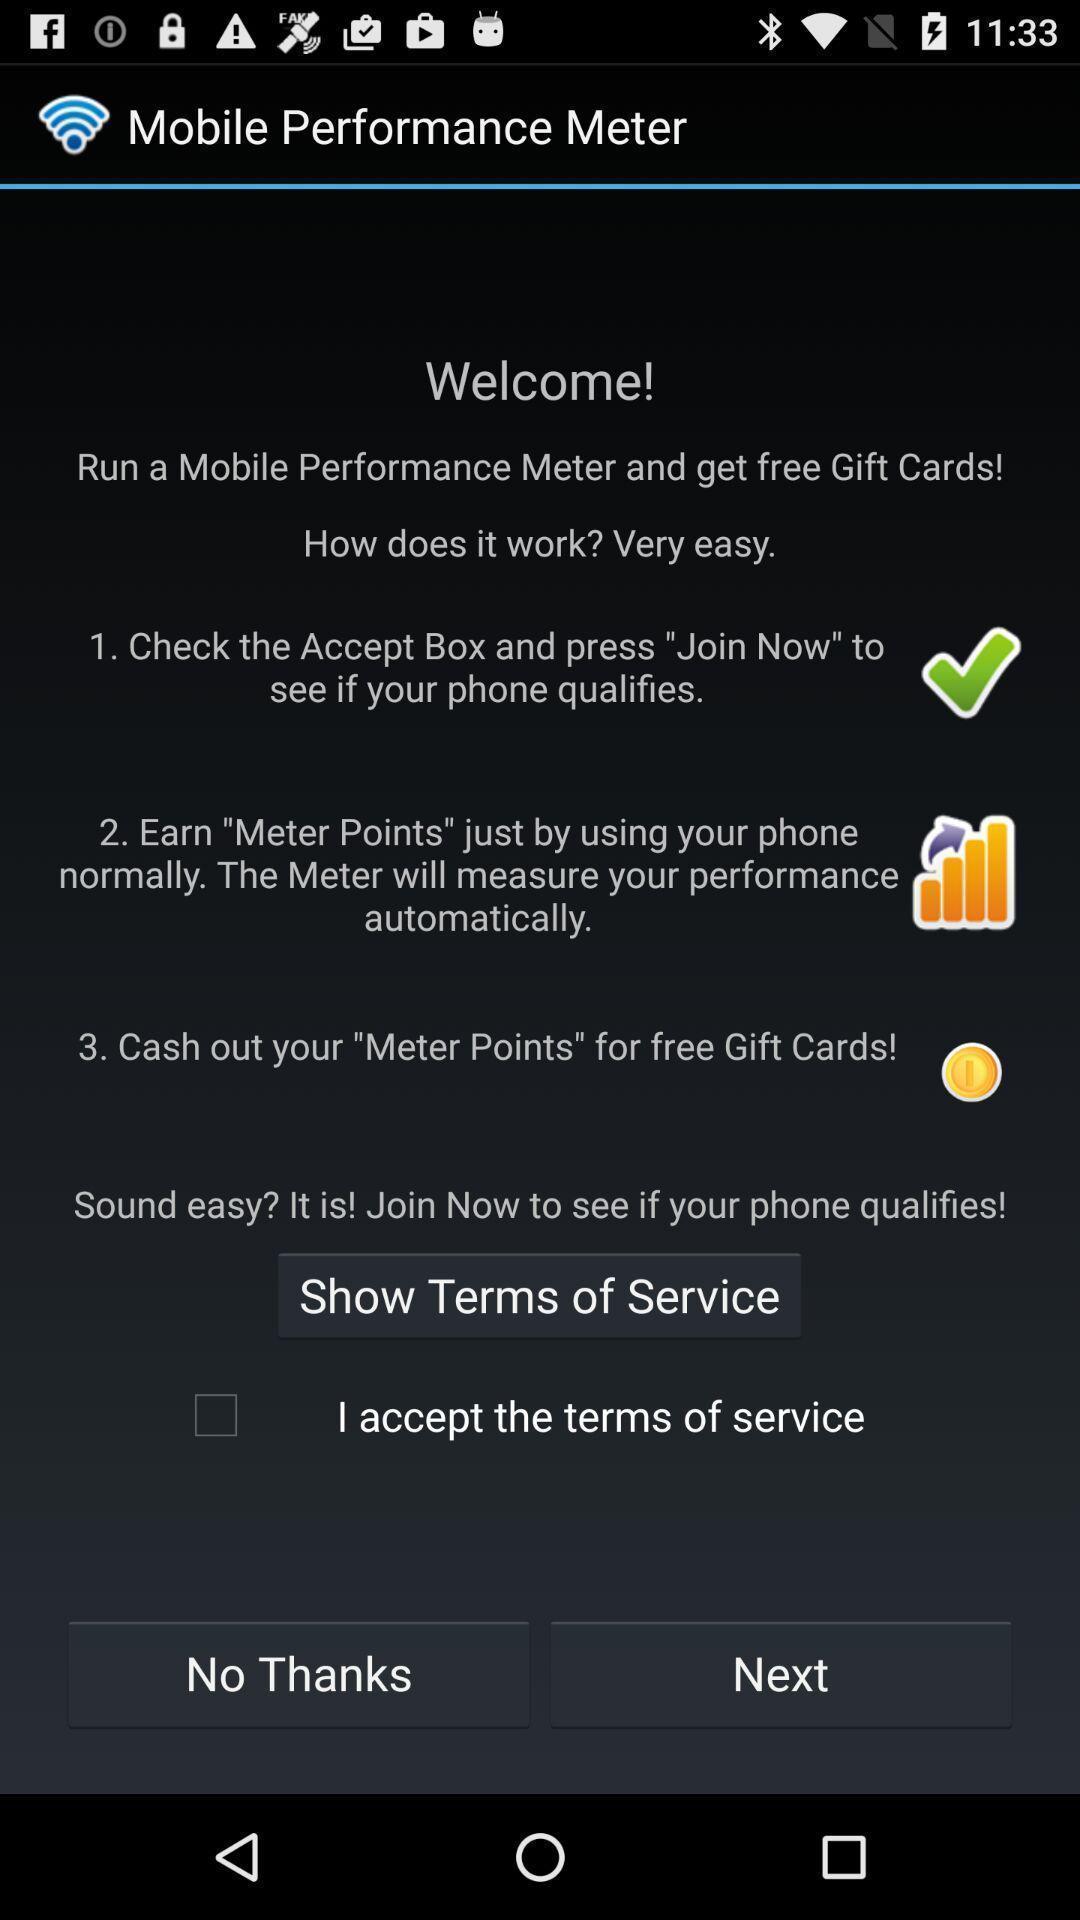Tell me what you see in this picture. Welcome page of a performance meter. 